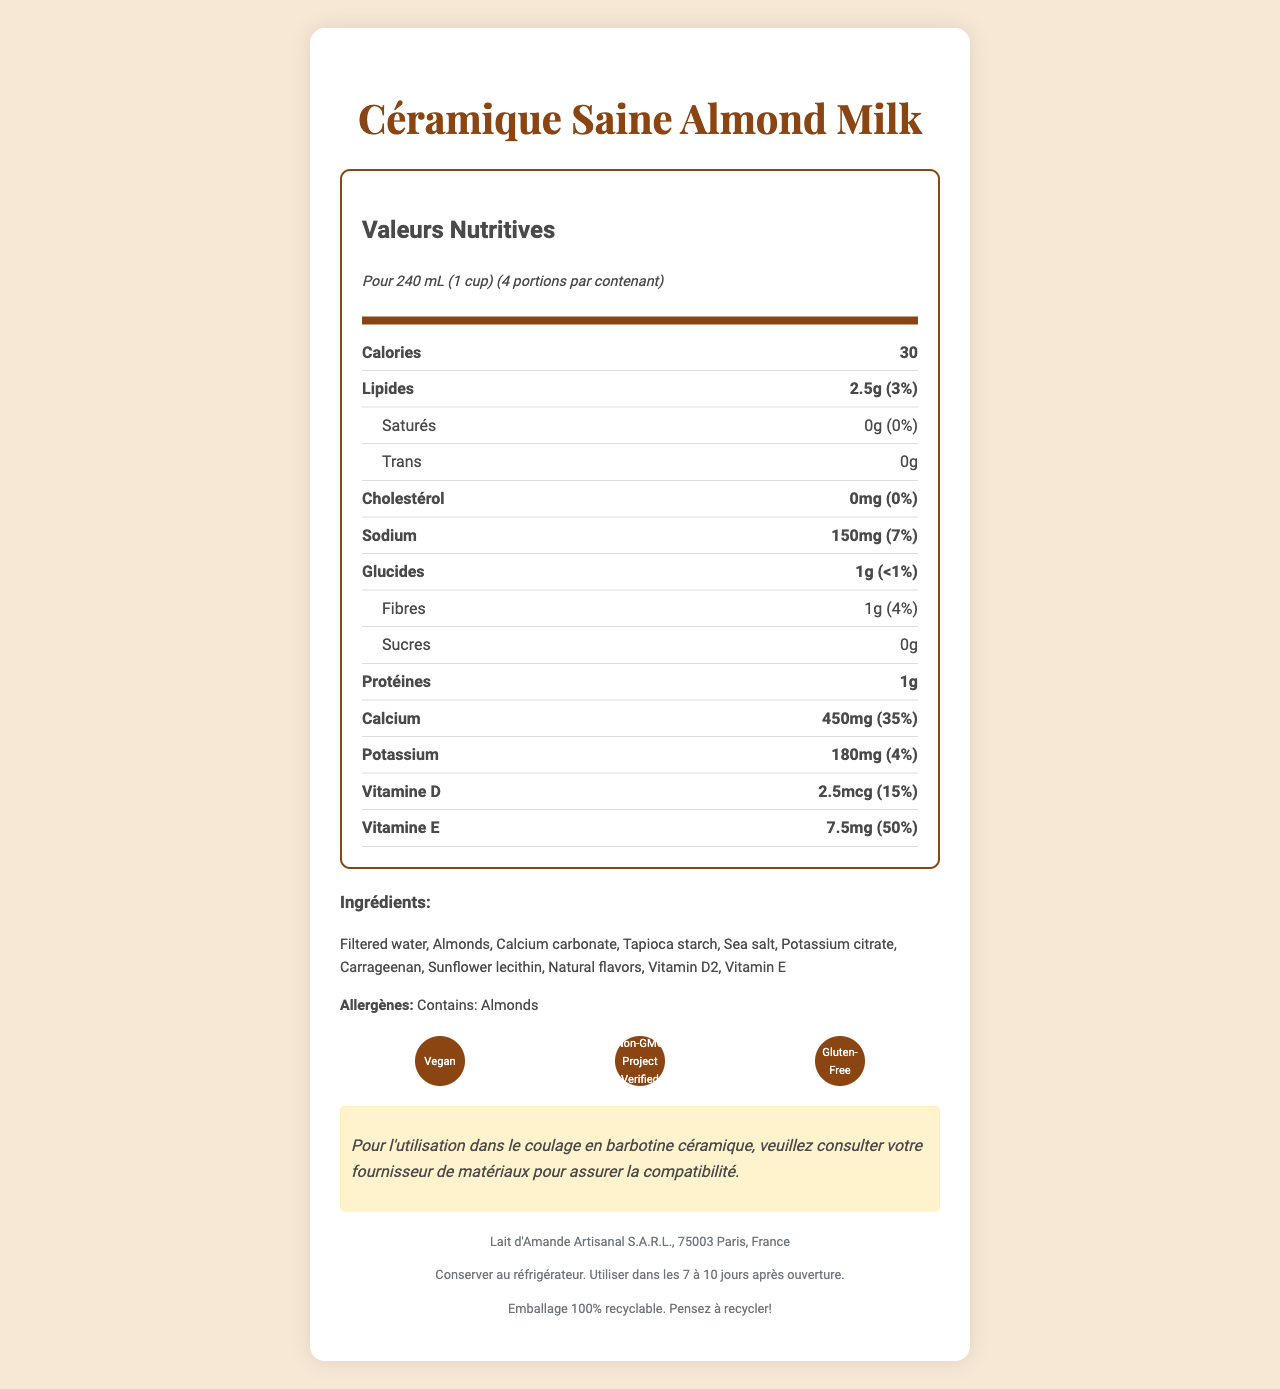what is the calories per serving? According to the document, the calories per serving are listed as 30.
Answer: 30 how many servings are there per container? The document states that there are 4 servings per container.
Answer: 4 what is the amount of total fat per serving? The total fat per serving is listed as 2.5g in the document.
Answer: 2.5g what percentage of the daily value of calcium is provided per serving? The document specifies that the calcium per serving is 450mg, which is 35% of the daily value.
Answer: 35% how much protein is in one serving? The document indicates that there is 1g of protein per serving.
Answer: 1g how many grams of dietary fiber are in one serving? One serving contains 1g of dietary fiber, as per the document.
Answer: 1g what are the main ingredients of "Céramique Saine Almond Milk"? A. Almonds, Sea Salt B. Filtered Water, Almonds, Calcium Carbonate, Tapioca Starch C. Tapioca Starch, Sea Salt, Potassium Citrate D. Almonds, Natural Flavors, Vitamin D The main ingredients listed are: Filtered water, Almonds, Calcium carbonate, Tapioca starch.
Answer: B which certification is not mentioned for this product? 1. Vegan 2. Non-GMO Project Verified 3. Halal 4. Gluten-Free The document mentions certifications such as Vegan, Non-GMO Project Verified, and Gluten-Free, but does not mention Halal.
Answer: 3. Halal does this product contain any cholesterol? The cholesterol content per serving is listed as 0mg, indicating it contains no cholesterol.
Answer: No what should you consult with your material supplier for when using this product in ceramic slip casting? The document has a warning that states you should consult your supplier for compatibility when using this product in ceramic slip casting.
Answer: Compatibility summarize the document in a few sentences. The summary gives an overview of the nutritional labels, ingredients, certifications, and additional warnings or storage instructions found in the document.
Answer: The document provides nutritional information for "Céramique Saine Almond Milk", listing key nutrients and their daily values. It includes ingredient information, allergen warnings, and storage instructions. The product is certified Vegan, Non-GMO Project Verified, and Gluten-Free. There is also a specific warning regarding its use in ceramic slip casting. where is the product manufactured? The document indicates that the product is manufactured by Lait d'Amande Artisanal S.A.R.L. in 75003 Paris, France.
Answer: 75003 Paris, France can the amount of Vitamin C in the product be determined from the document? The document does not include any information about the amount of Vitamin C in the product, making it impossible to determine.
Answer: Not enough information 